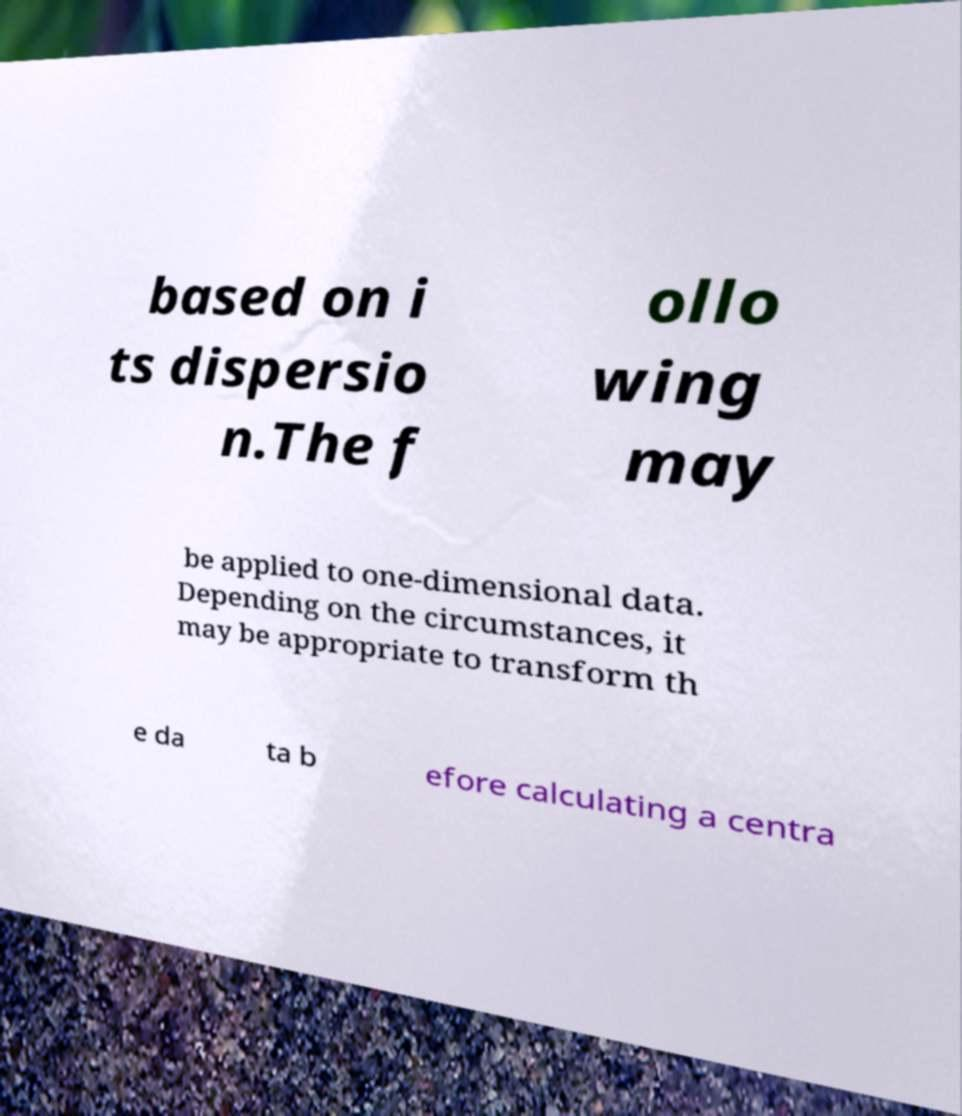Please identify and transcribe the text found in this image. based on i ts dispersio n.The f ollo wing may be applied to one-dimensional data. Depending on the circumstances, it may be appropriate to transform th e da ta b efore calculating a centra 